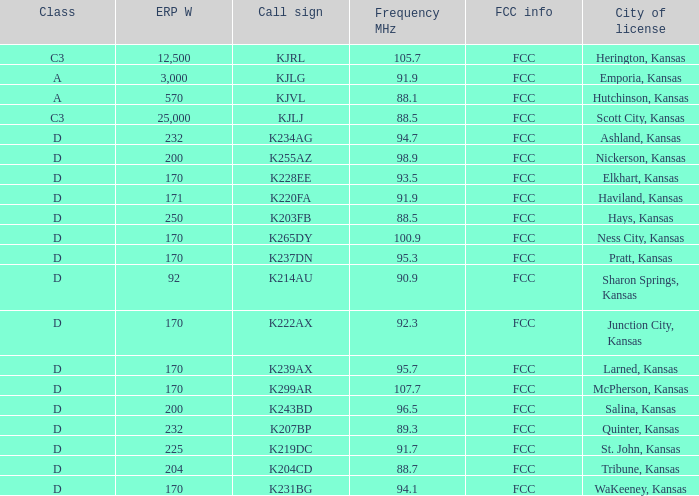Class of d, and a Frequency MHz smaller than 107.7, and a ERP W smaller than 232 has what call sign? K255AZ, K228EE, K220FA, K265DY, K237DN, K214AU, K222AX, K239AX, K243BD, K219DC, K204CD, K231BG. 